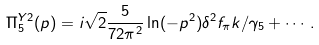<formula> <loc_0><loc_0><loc_500><loc_500>\Pi ^ { Y 2 } _ { 5 } ( p ) = i \sqrt { 2 } \frac { 5 } { 7 2 \pi ^ { 2 } } \ln ( - p ^ { 2 } ) \delta ^ { 2 } f _ { \pi } k / \gamma _ { 5 } + \cdots .</formula> 